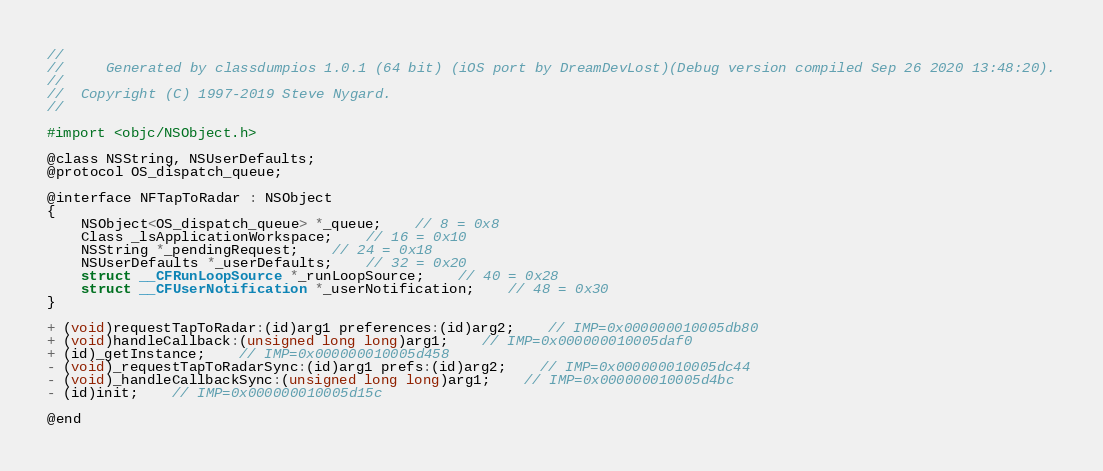Convert code to text. <code><loc_0><loc_0><loc_500><loc_500><_C_>//
//     Generated by classdumpios 1.0.1 (64 bit) (iOS port by DreamDevLost)(Debug version compiled Sep 26 2020 13:48:20).
//
//  Copyright (C) 1997-2019 Steve Nygard.
//

#import <objc/NSObject.h>

@class NSString, NSUserDefaults;
@protocol OS_dispatch_queue;

@interface NFTapToRadar : NSObject
{
    NSObject<OS_dispatch_queue> *_queue;	// 8 = 0x8
    Class _lsApplicationWorkspace;	// 16 = 0x10
    NSString *_pendingRequest;	// 24 = 0x18
    NSUserDefaults *_userDefaults;	// 32 = 0x20
    struct __CFRunLoopSource *_runLoopSource;	// 40 = 0x28
    struct __CFUserNotification *_userNotification;	// 48 = 0x30
}

+ (void)requestTapToRadar:(id)arg1 preferences:(id)arg2;	// IMP=0x000000010005db80
+ (void)handleCallback:(unsigned long long)arg1;	// IMP=0x000000010005daf0
+ (id)_getInstance;	// IMP=0x000000010005d458
- (void)_requestTapToRadarSync:(id)arg1 prefs:(id)arg2;	// IMP=0x000000010005dc44
- (void)_handleCallbackSync:(unsigned long long)arg1;	// IMP=0x000000010005d4bc
- (id)init;	// IMP=0x000000010005d15c

@end

</code> 